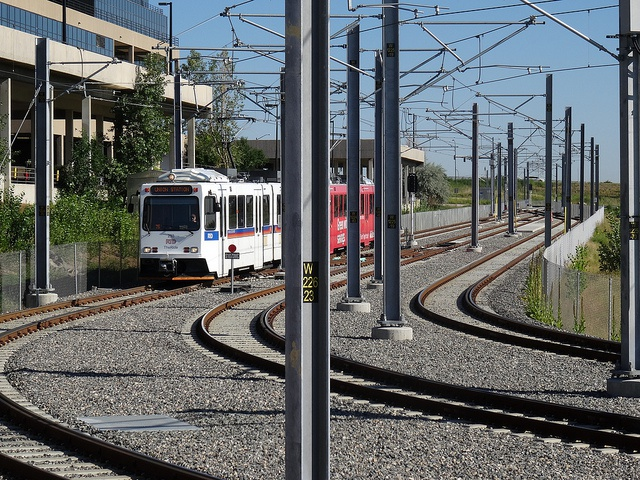Describe the objects in this image and their specific colors. I can see train in tan, black, white, darkgray, and gray tones and people in tan, black, and gray tones in this image. 